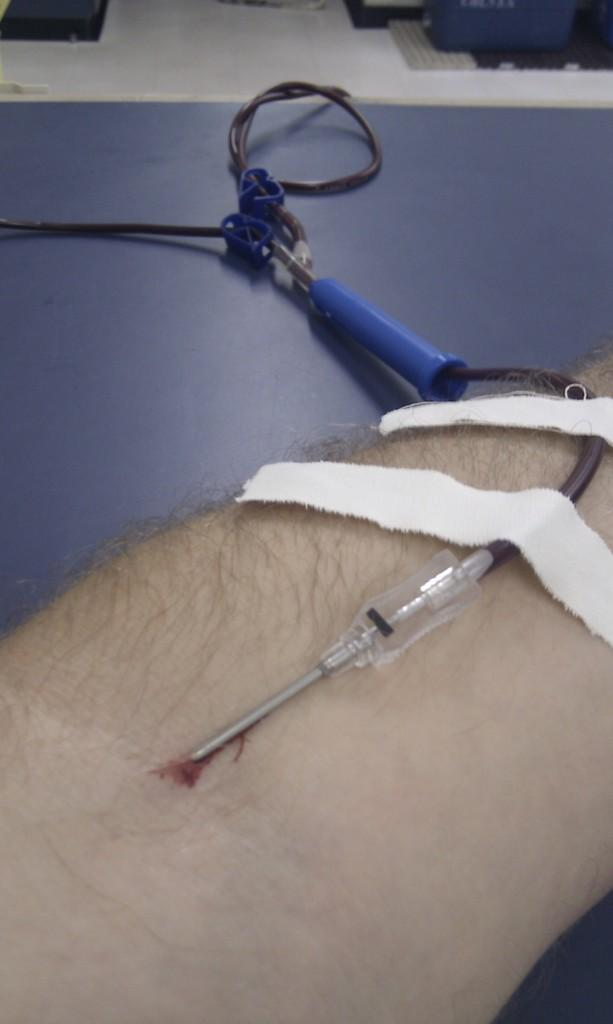What part of a person is visible in the image? There is a hand of a person in the image. What medical device is present in the image? There is a saline tube with a needle in the image. What type of first aid item can be seen in the image? There are plasters in the image. How much honey is present in the image? There is no honey present in the image. What is the duration of the event taking place in the image? The image does not depict an event, so there is no duration to consider. 